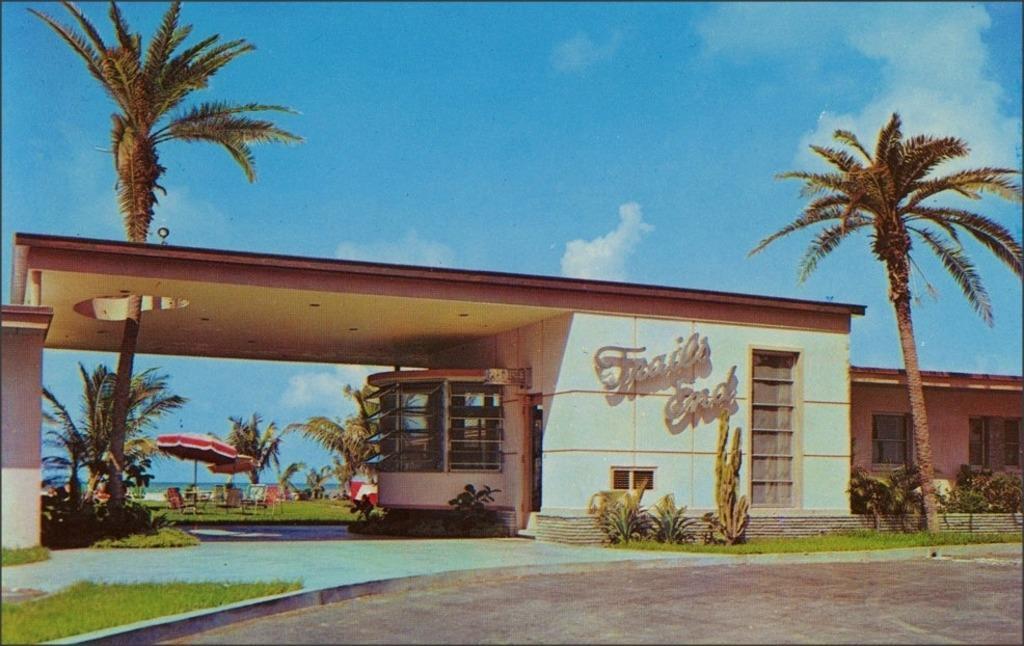Please provide a concise description of this image. There is a building which has something written on it and there are trees and a greenery ground in the background. 